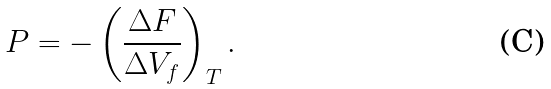<formula> <loc_0><loc_0><loc_500><loc_500>P = - \left ( \frac { { \Delta } F } { { \Delta } V _ { f } } \right ) _ { T } .</formula> 